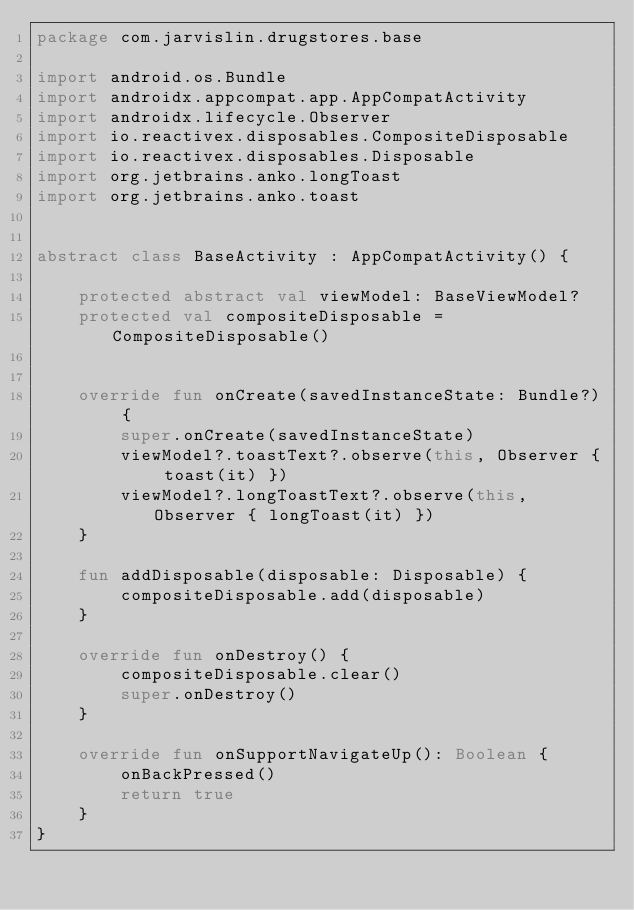Convert code to text. <code><loc_0><loc_0><loc_500><loc_500><_Kotlin_>package com.jarvislin.drugstores.base

import android.os.Bundle
import androidx.appcompat.app.AppCompatActivity
import androidx.lifecycle.Observer
import io.reactivex.disposables.CompositeDisposable
import io.reactivex.disposables.Disposable
import org.jetbrains.anko.longToast
import org.jetbrains.anko.toast


abstract class BaseActivity : AppCompatActivity() {

    protected abstract val viewModel: BaseViewModel?
    protected val compositeDisposable = CompositeDisposable()


    override fun onCreate(savedInstanceState: Bundle?) {
        super.onCreate(savedInstanceState)
        viewModel?.toastText?.observe(this, Observer { toast(it) })
        viewModel?.longToastText?.observe(this, Observer { longToast(it) })
    }

    fun addDisposable(disposable: Disposable) {
        compositeDisposable.add(disposable)
    }

    override fun onDestroy() {
        compositeDisposable.clear()
        super.onDestroy()
    }

    override fun onSupportNavigateUp(): Boolean {
        onBackPressed()
        return true
    }
}</code> 